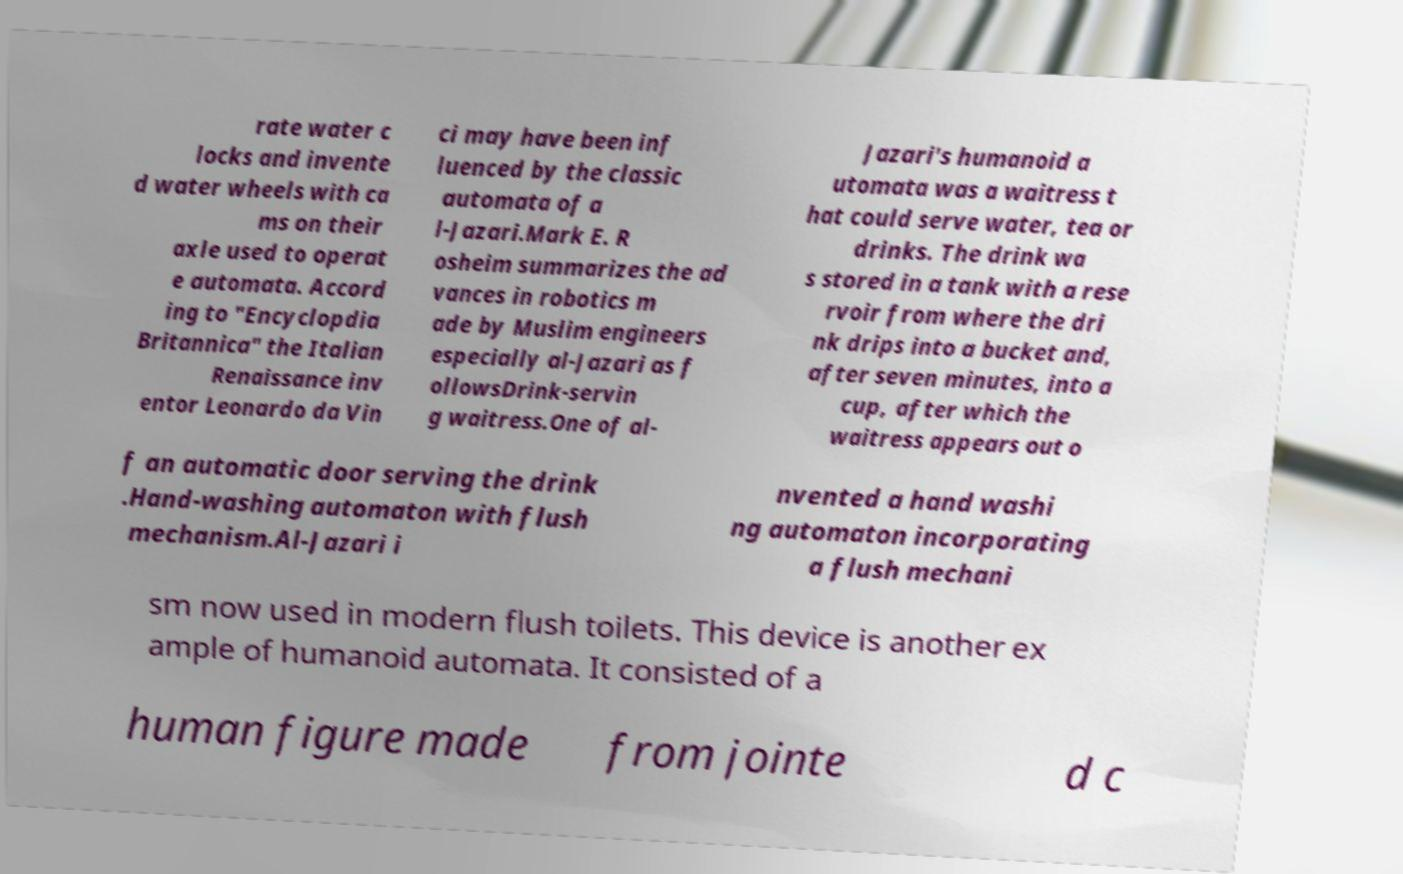Please identify and transcribe the text found in this image. rate water c locks and invente d water wheels with ca ms on their axle used to operat e automata. Accord ing to "Encyclopdia Britannica" the Italian Renaissance inv entor Leonardo da Vin ci may have been inf luenced by the classic automata of a l-Jazari.Mark E. R osheim summarizes the ad vances in robotics m ade by Muslim engineers especially al-Jazari as f ollowsDrink-servin g waitress.One of al- Jazari's humanoid a utomata was a waitress t hat could serve water, tea or drinks. The drink wa s stored in a tank with a rese rvoir from where the dri nk drips into a bucket and, after seven minutes, into a cup, after which the waitress appears out o f an automatic door serving the drink .Hand-washing automaton with flush mechanism.Al-Jazari i nvented a hand washi ng automaton incorporating a flush mechani sm now used in modern flush toilets. This device is another ex ample of humanoid automata. It consisted of a human figure made from jointe d c 